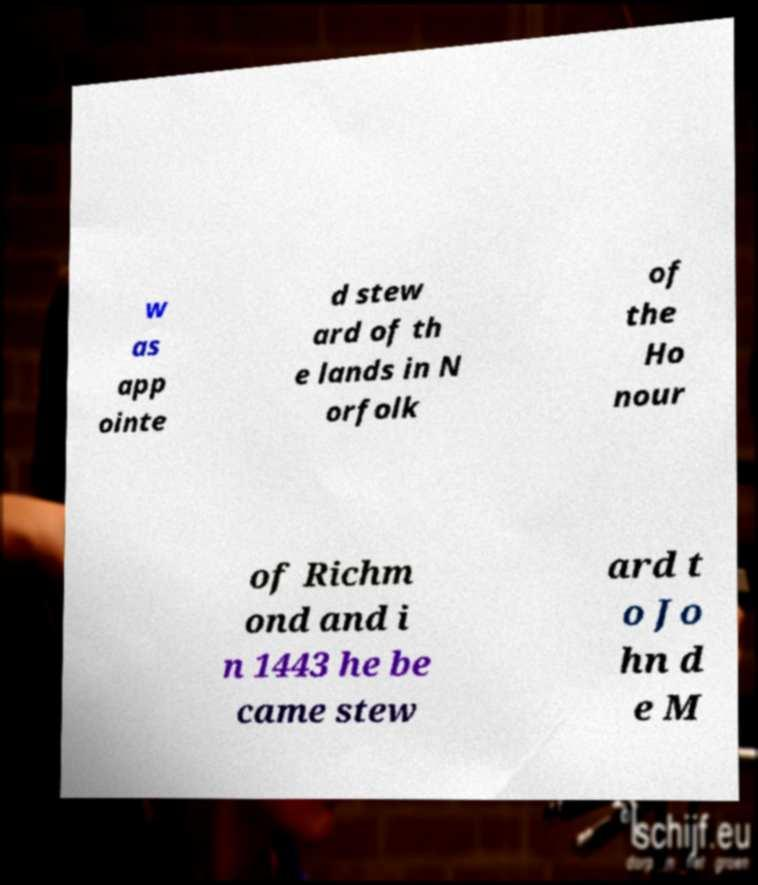Can you accurately transcribe the text from the provided image for me? w as app ointe d stew ard of th e lands in N orfolk of the Ho nour of Richm ond and i n 1443 he be came stew ard t o Jo hn d e M 